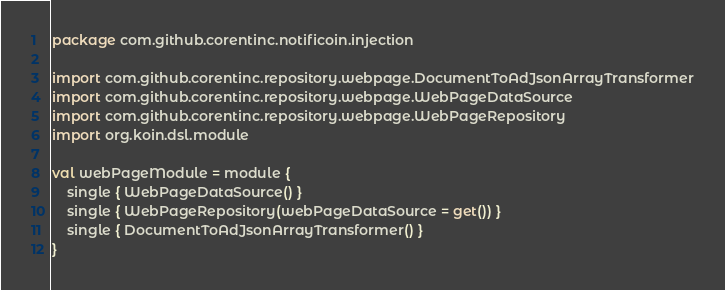Convert code to text. <code><loc_0><loc_0><loc_500><loc_500><_Kotlin_>package com.github.corentinc.notificoin.injection

import com.github.corentinc.repository.webpage.DocumentToAdJsonArrayTransformer
import com.github.corentinc.repository.webpage.WebPageDataSource
import com.github.corentinc.repository.webpage.WebPageRepository
import org.koin.dsl.module

val webPageModule = module {
	single { WebPageDataSource() }
    single { WebPageRepository(webPageDataSource = get()) }
	single { DocumentToAdJsonArrayTransformer() }
}</code> 